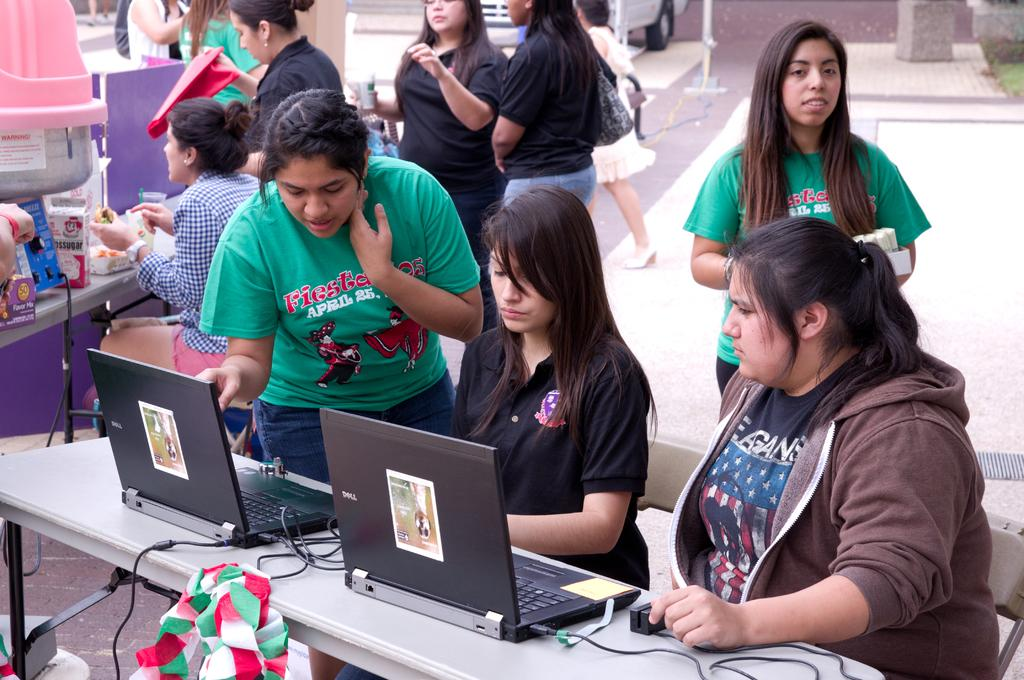<image>
Write a terse but informative summary of the picture. Several students are working on their project together and one of the students is wearing a shirt that says "fiesta". 